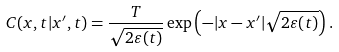<formula> <loc_0><loc_0><loc_500><loc_500>C ( x , t | x ^ { \prime } , t ) = \frac { T } { \sqrt { 2 \varepsilon ( t ) } } \exp \left ( - | x - x ^ { \prime } | \sqrt { 2 \varepsilon ( t ) } \right ) .</formula> 